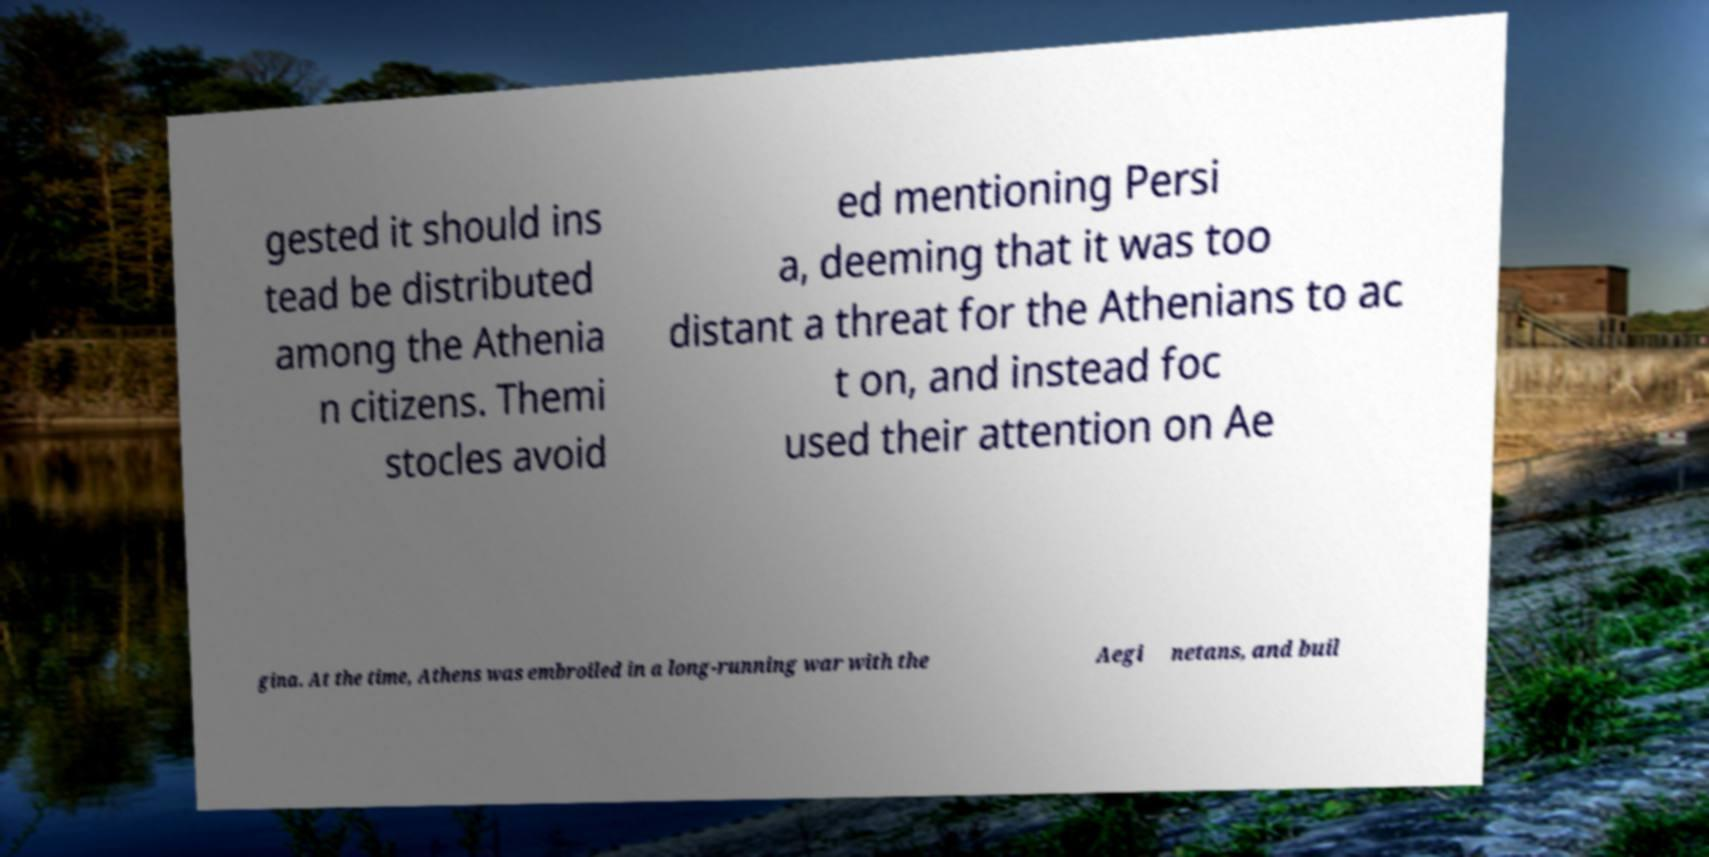Can you accurately transcribe the text from the provided image for me? gested it should ins tead be distributed among the Athenia n citizens. Themi stocles avoid ed mentioning Persi a, deeming that it was too distant a threat for the Athenians to ac t on, and instead foc used their attention on Ae gina. At the time, Athens was embroiled in a long-running war with the Aegi netans, and buil 